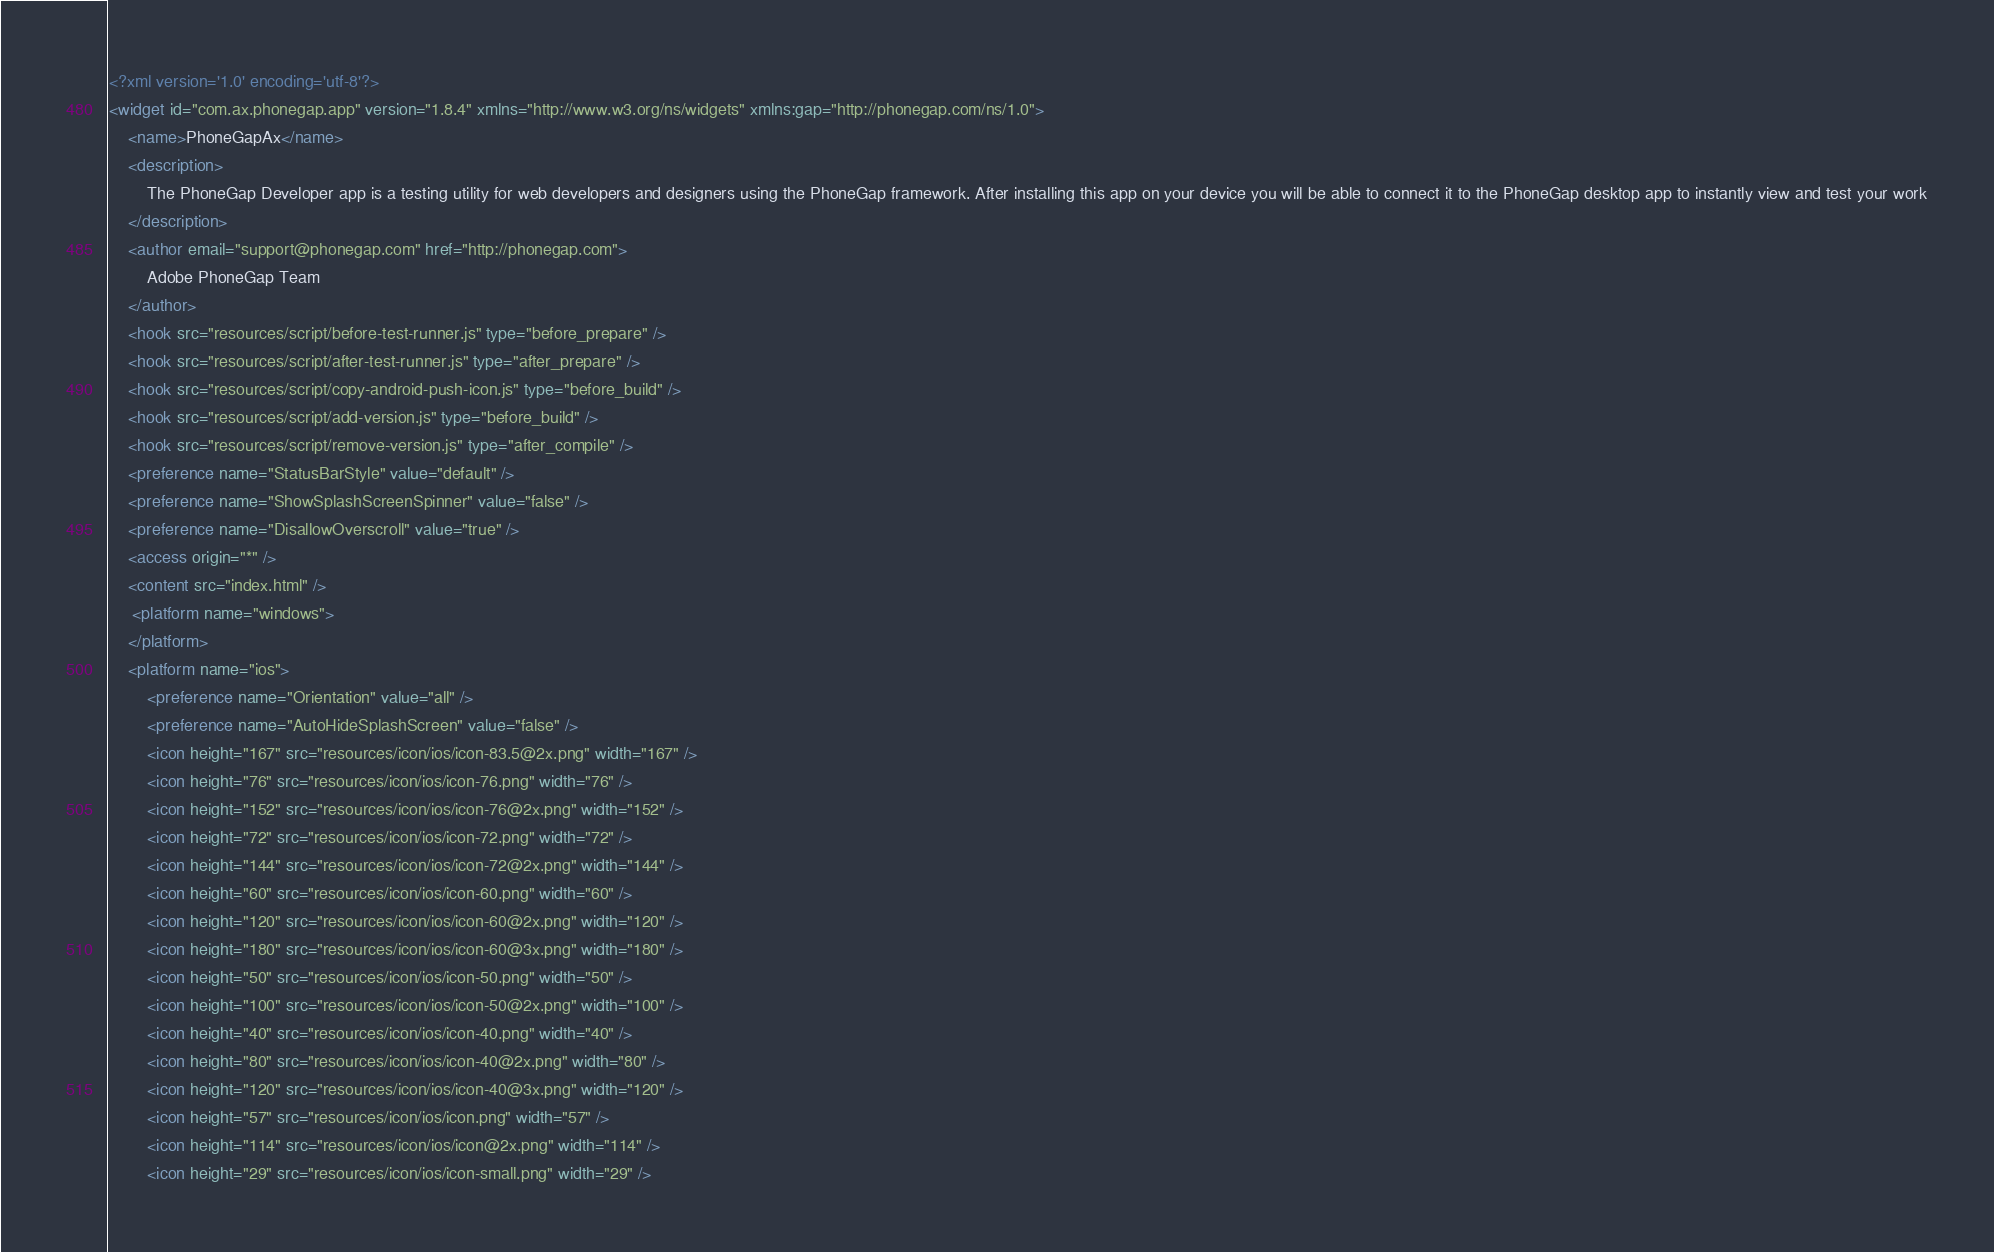<code> <loc_0><loc_0><loc_500><loc_500><_XML_><?xml version='1.0' encoding='utf-8'?>
<widget id="com.ax.phonegap.app" version="1.8.4" xmlns="http://www.w3.org/ns/widgets" xmlns:gap="http://phonegap.com/ns/1.0">
    <name>PhoneGapAx</name>
    <description>
        The PhoneGap Developer app is a testing utility for web developers and designers using the PhoneGap framework. After installing this app on your device you will be able to connect it to the PhoneGap desktop app to instantly view and test your work
    </description>
    <author email="support@phonegap.com" href="http://phonegap.com">
        Adobe PhoneGap Team
    </author>
    <hook src="resources/script/before-test-runner.js" type="before_prepare" />
    <hook src="resources/script/after-test-runner.js" type="after_prepare" />
    <hook src="resources/script/copy-android-push-icon.js" type="before_build" />
    <hook src="resources/script/add-version.js" type="before_build" />
    <hook src="resources/script/remove-version.js" type="after_compile" />
    <preference name="StatusBarStyle" value="default" />
    <preference name="ShowSplashScreenSpinner" value="false" />
    <preference name="DisallowOverscroll" value="true" />
    <access origin="*" />
    <content src="index.html" />
     <platform name="windows">
    </platform>
    <platform name="ios">
        <preference name="Orientation" value="all" />
        <preference name="AutoHideSplashScreen" value="false" />
        <icon height="167" src="resources/icon/ios/icon-83.5@2x.png" width="167" />
        <icon height="76" src="resources/icon/ios/icon-76.png" width="76" />
        <icon height="152" src="resources/icon/ios/icon-76@2x.png" width="152" />
        <icon height="72" src="resources/icon/ios/icon-72.png" width="72" />
        <icon height="144" src="resources/icon/ios/icon-72@2x.png" width="144" />
        <icon height="60" src="resources/icon/ios/icon-60.png" width="60" />
        <icon height="120" src="resources/icon/ios/icon-60@2x.png" width="120" />
        <icon height="180" src="resources/icon/ios/icon-60@3x.png" width="180" />
        <icon height="50" src="resources/icon/ios/icon-50.png" width="50" />
        <icon height="100" src="resources/icon/ios/icon-50@2x.png" width="100" />
        <icon height="40" src="resources/icon/ios/icon-40.png" width="40" />
        <icon height="80" src="resources/icon/ios/icon-40@2x.png" width="80" />
        <icon height="120" src="resources/icon/ios/icon-40@3x.png" width="120" />
        <icon height="57" src="resources/icon/ios/icon.png" width="57" />
        <icon height="114" src="resources/icon/ios/icon@2x.png" width="114" />
        <icon height="29" src="resources/icon/ios/icon-small.png" width="29" /></code> 